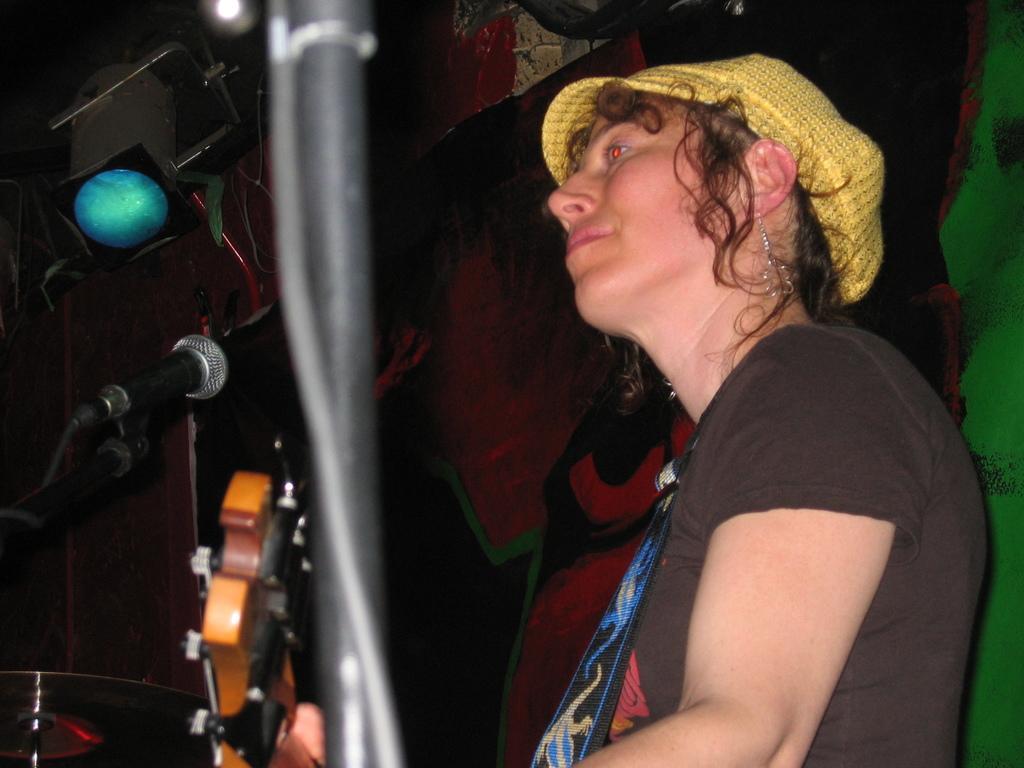How would you summarize this image in a sentence or two? In this picture we can see that a woman wearing black t- shirt is smiling and playing with the wooden guitar. On the top we can see blue color spotlight. 